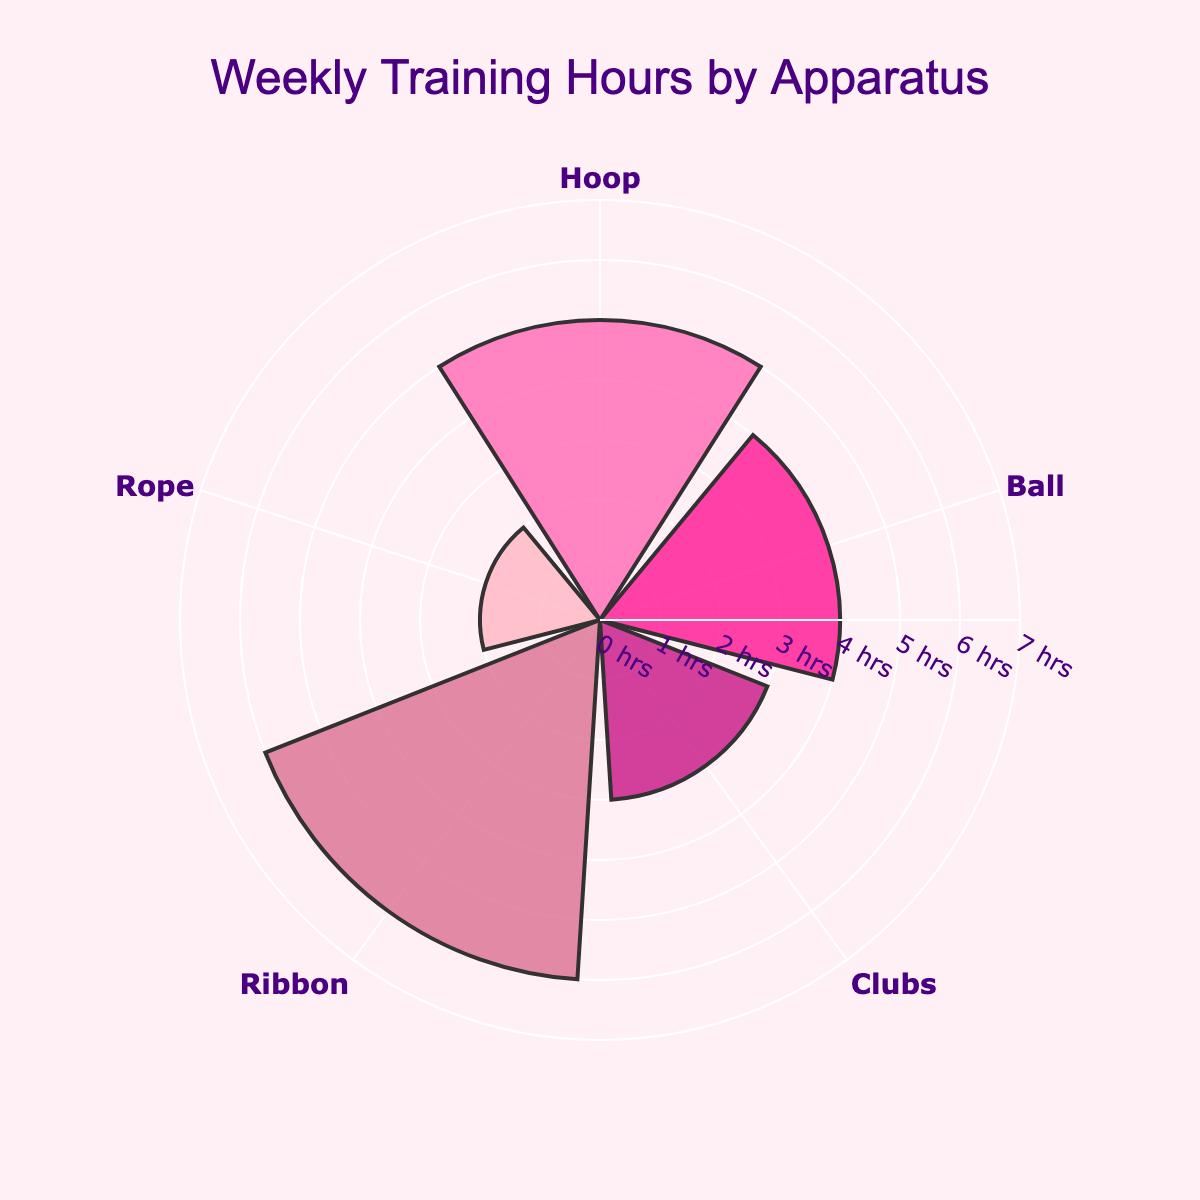What's the total number of weekly training hours spent on all apparatus? Sum the weekly training hours for each apparatus: 5 (Hoop) + 4 (Ball) + 3 (Clubs) + 6 (Ribbon) + 2 (Rope) = 20.
Answer: 20 Which apparatus has the highest weekly training hours? The Ribbon has the highest bar in the rose chart, indicating 6 hours of training per week.
Answer: Ribbon How many more hours are spent on the Ribbon compared to the Rope? Ribbon has 6 hours while Rope has 2 hours. The difference is 6 - 2 = 4 hours.
Answer: 4 What is the average number of weekly training hours spent across all apparatus? The total number of hours is 20, and there are 5 apparatus. The average is 20 / 5 = 4 hours.
Answer: 4 Which apparatus has the least number of weekly training hours? The Rope has the shortest bar in the rose chart, indicating 2 hours of training per week.
Answer: Rope What is the total number of weekly training hours spent on Hoop and Ball combined? Hoop has 5 hours and Ball has 4 hours. The combined total is 5 + 4 = 9 hours.
Answer: 9 How many apparatus are there with weekly training hours greater than 4 hours? Only Ribbon (6 hours) and Hoop (5 hours) have more than 4 hours of training per week.
Answer: 2 What is the difference in weekly training hours between the apparatus with the highest and lowest hours? The Ribbon has the highest at 6 hours, and the Rope has the lowest at 2 hours. The difference is 6 - 2 = 4 hours.
Answer: 4 Between Ball, Clubs, and Rope, which apparatus has the highest weekly training hours? Among Ball (4 hours), Clubs (3 hours), and Rope (2 hours), the Ball has the highest weekly training hours.
Answer: Ball In terms of color, which apparatus is represented by the darkest shade in the rose chart? The Ribbon is represented by the darkest shade of color in the rose chart.
Answer: Ribbon 